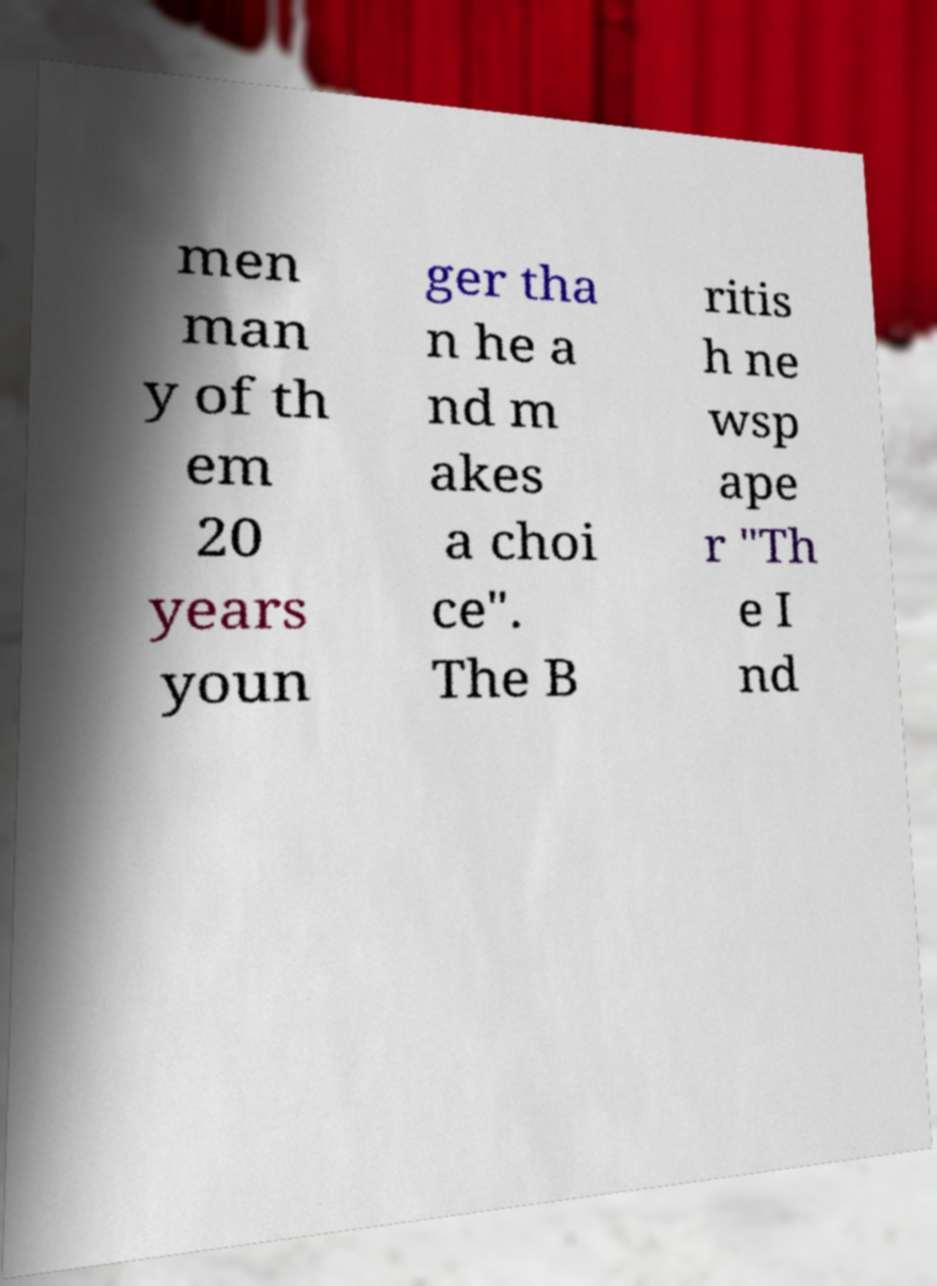Please identify and transcribe the text found in this image. men man y of th em 20 years youn ger tha n he a nd m akes a choi ce". The B ritis h ne wsp ape r "Th e I nd 